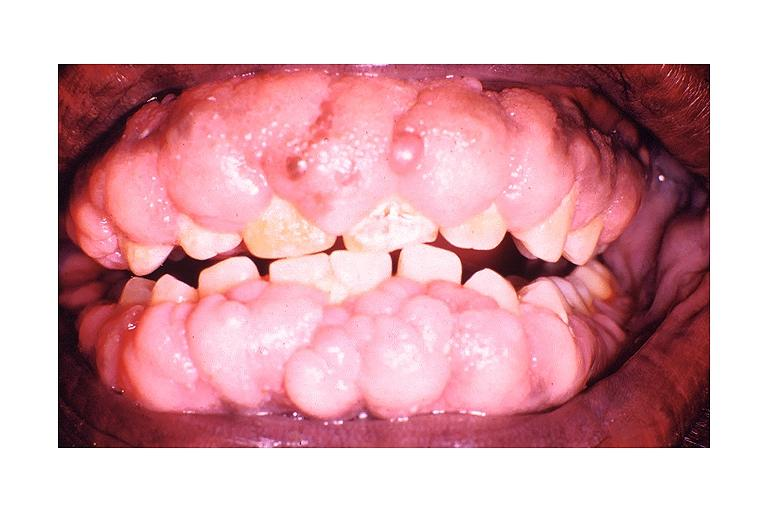does this image show dilantin induced gingival hyperplasia?
Answer the question using a single word or phrase. Yes 